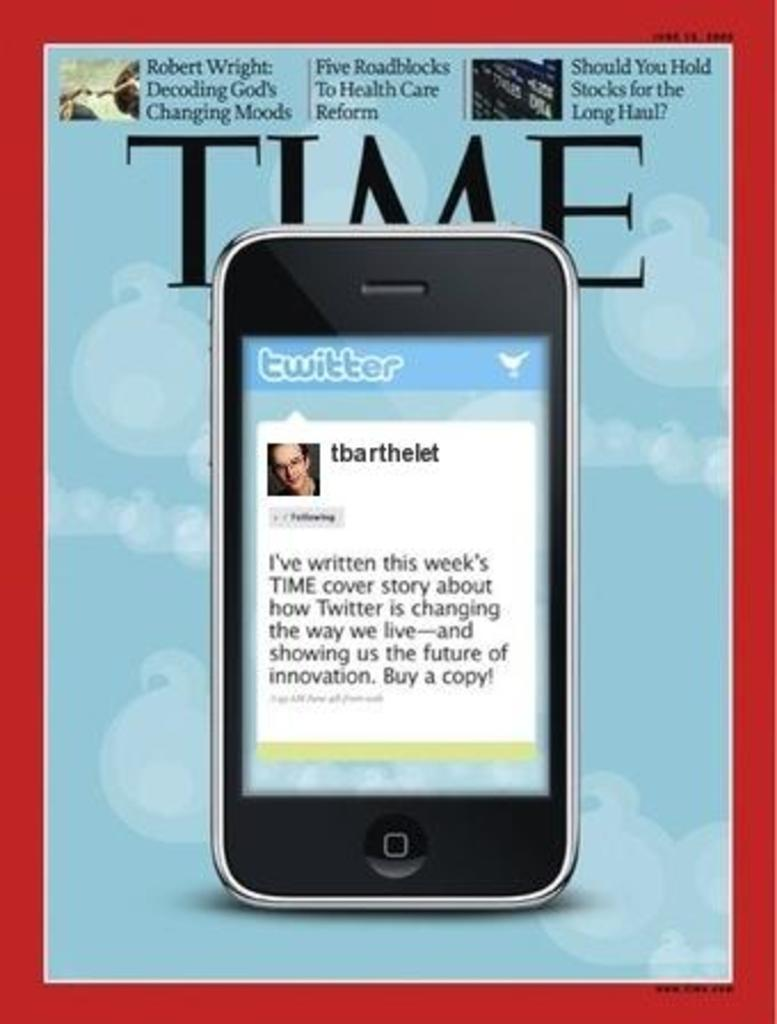<image>
Present a compact description of the photo's key features. A smart phone open to Twitter sitting on a copy of Time. 